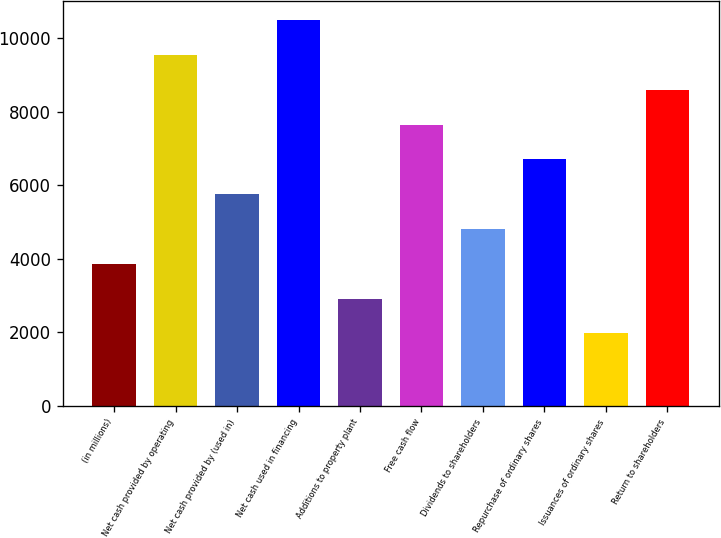<chart> <loc_0><loc_0><loc_500><loc_500><bar_chart><fcel>(in millions)<fcel>Net cash provided by operating<fcel>Net cash provided by (used in)<fcel>Net cash used in financing<fcel>Additions to property plant<fcel>Free cash flow<fcel>Dividends to shareholders<fcel>Repurchase of ordinary shares<fcel>Issuances of ordinary shares<fcel>Return to shareholders<nl><fcel>3868.8<fcel>9543<fcel>5760.2<fcel>10488.7<fcel>2923.1<fcel>7651.6<fcel>4814.5<fcel>6705.9<fcel>1977.4<fcel>8597.3<nl></chart> 